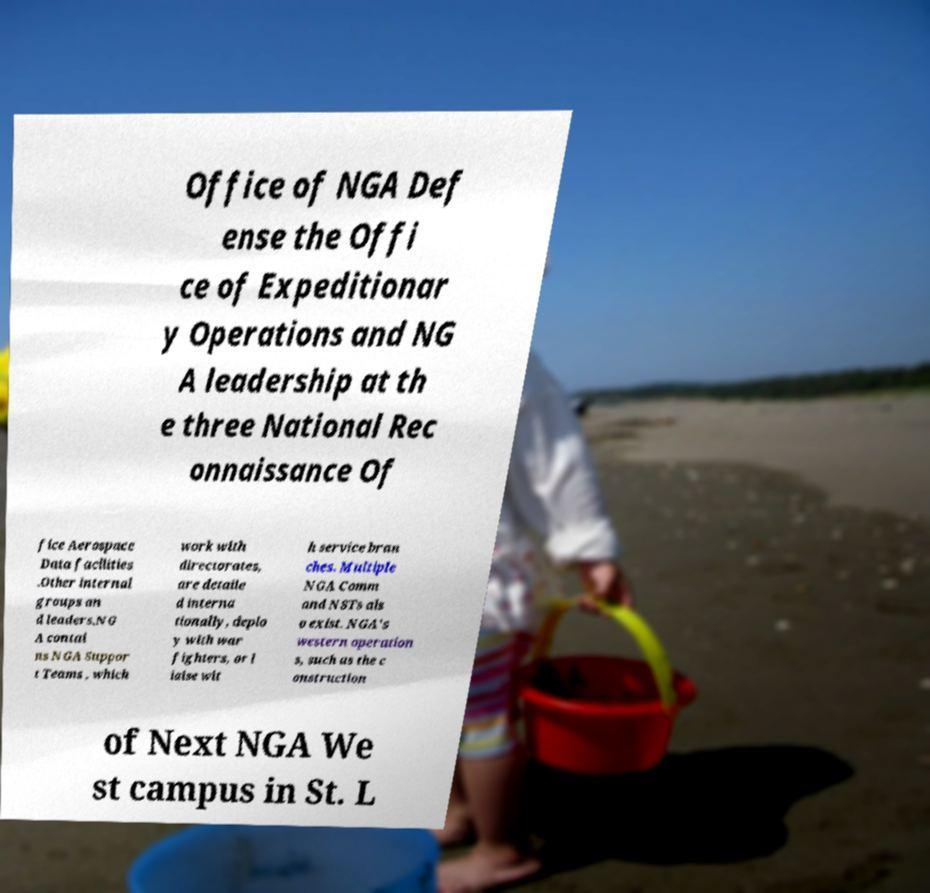What messages or text are displayed in this image? I need them in a readable, typed format. Office of NGA Def ense the Offi ce of Expeditionar y Operations and NG A leadership at th e three National Rec onnaissance Of fice Aerospace Data facilities .Other internal groups an d leaders.NG A contai ns NGA Suppor t Teams , which work with directorates, are detaile d interna tionally, deplo y with war fighters, or l iaise wit h service bran ches. Multiple NGA Comm and NSTs als o exist. NGA's western operation s, such as the c onstruction of Next NGA We st campus in St. L 